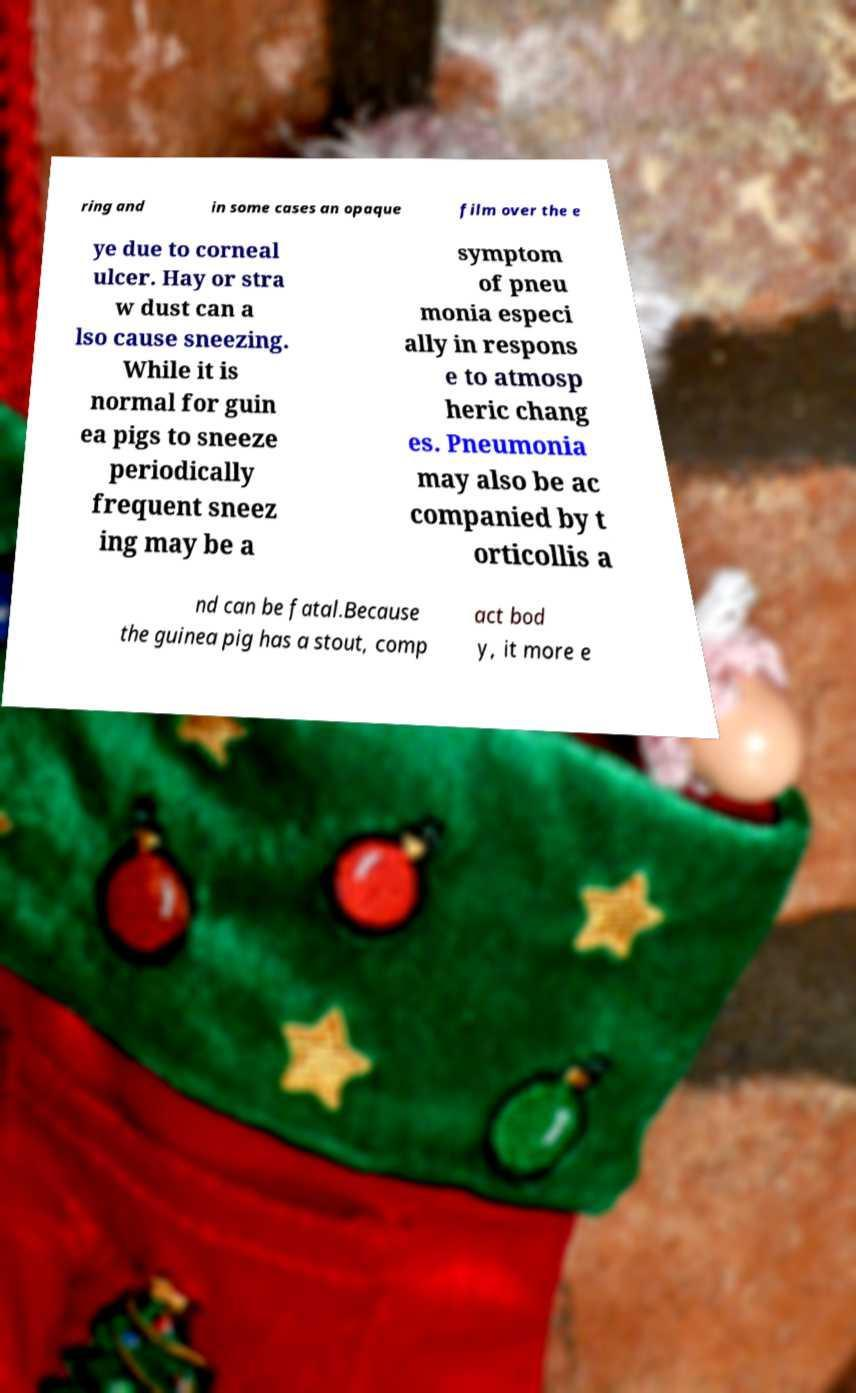Can you read and provide the text displayed in the image?This photo seems to have some interesting text. Can you extract and type it out for me? ring and in some cases an opaque film over the e ye due to corneal ulcer. Hay or stra w dust can a lso cause sneezing. While it is normal for guin ea pigs to sneeze periodically frequent sneez ing may be a symptom of pneu monia especi ally in respons e to atmosp heric chang es. Pneumonia may also be ac companied by t orticollis a nd can be fatal.Because the guinea pig has a stout, comp act bod y, it more e 